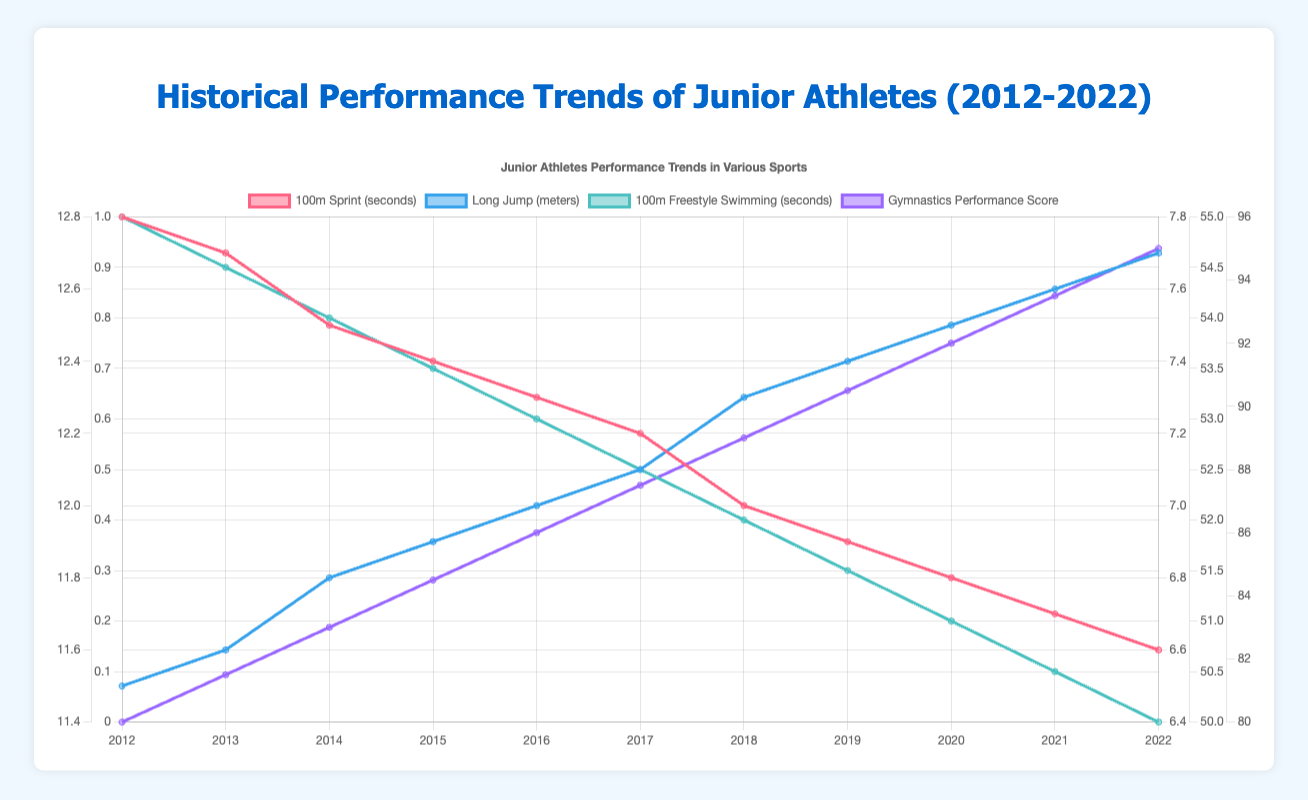What's the trend in average 100m sprint time for Track and Field over the decade? Observe the line representing the average 100m sprint time for Track and Field from 2012 to 2022. It shows a consistently declining trend. The time decreases from 12.8 seconds to 11.6 seconds over the ten-year period.
Answer: Decreasing trend How has the long jump distance for Track and Field changed from 2012 to 2022? Check the line representing long jump distances for Track and Field. It starts at 6.5 meters in 2012 and ends at 7.7 meters in 2022, showing a consistent increase over the decade.
Answer: Increased by 1.2 meters Compare the trend of average 100m freestyle times in Swimming to that of the 100m sprint times in Track and Field. Both lines representing these times show a decreasing trend. The 100m freestyle time decreases from 55.0 seconds in 2012 to 50.0 seconds in 2022, while the 100m sprint time falls from 12.8 seconds in 2012 to 11.6 seconds in 2022.
Answer: Both decreased What is the difference between the average long jump distance in 2022 and 2018 in Track and Field? In 2018, the average long jump distance is 7.3 meters, and in 2022, it is 7.7 meters. Subtract the 2018 value from the 2022 value to find the difference: 7.7 - 7.3 = 0.4 meters.
Answer: 0.4 meters What was the highest average gymnastics performance score over the decade, and in what year did this occur? Look at the line representing the gymnastics performance score; the highest point is 95.0, which occurs in 2022.
Answer: 95.0 in 2022 Did the average faults count in gymnastics increase or decrease from 2017 to 2019? Check the line for average faults count in gymnastics. From 2017 (1.5 faults) to 2019 (1.3 faults), the fault count decreases.
Answer: Decrease Between 2014 and 2016, which sport shows the greatest improvement in their respective performance metrics? Track and Field shows a decline in 100m time from 12.5 to 12.3 seconds, Swimming shows a decline in 100m freestyle time from 54.0 to 53.0 seconds, and Gymnastics shows an increase in performance score from 83.0 to 86.0. To determine the greatest improvement, consider the percentage change. Track and Field decreases by 1.6%, Swimming by 1.85%, and Gymnastics increases by 3.61%.
Answer: Gymnastics How does the change in discuss throw distance compare to the long jump distance in Track and Field between 2012 and 2022? The average discuss throw distance increases from 45.0 meters to 51.0 meters (an increase of 6 meters) while the long jump distance increases from 6.5 meters to 7.7 meters (an increase of 1.2 meters).
Answer: Discuss throw increased more What can be inferred about the performance trends in Swimming events over the decade? All swimming metrics shown have consistent improvements. The 100m freestyle, 200m butterfly, and 400m individual medley times all decrease, indicating better performance times over the decade.
Answer: Consistent improvement Which year shows the most dramatic improvement in any sport and metric? By comparing the slopes or changes year-on-year, 2020 shows a notable improvement in Gymnastics' performance score, rising from 90.5 in 2019 to 92.0 in 2020 (increase of 1.5 points).
Answer: 2020 in Gymnastics 